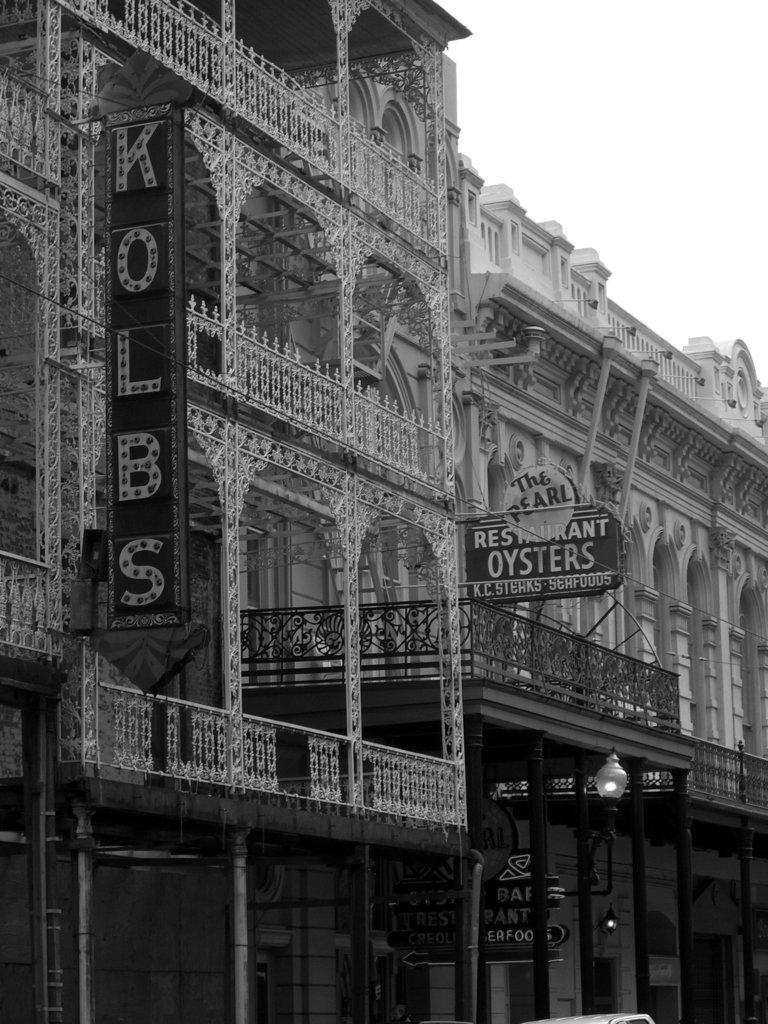What type of structures can be seen in the image? There are buildings in the image. What other objects can be seen in the image besides the buildings? There is a fence, a street lamp, and a banner in the image. What is visible at the top of the image? The sky is visible at the top of the image. Are there any pets visible in the image? There are no pets present in the image. Is there a volcano visible in the image? There is no volcano present in the image. 